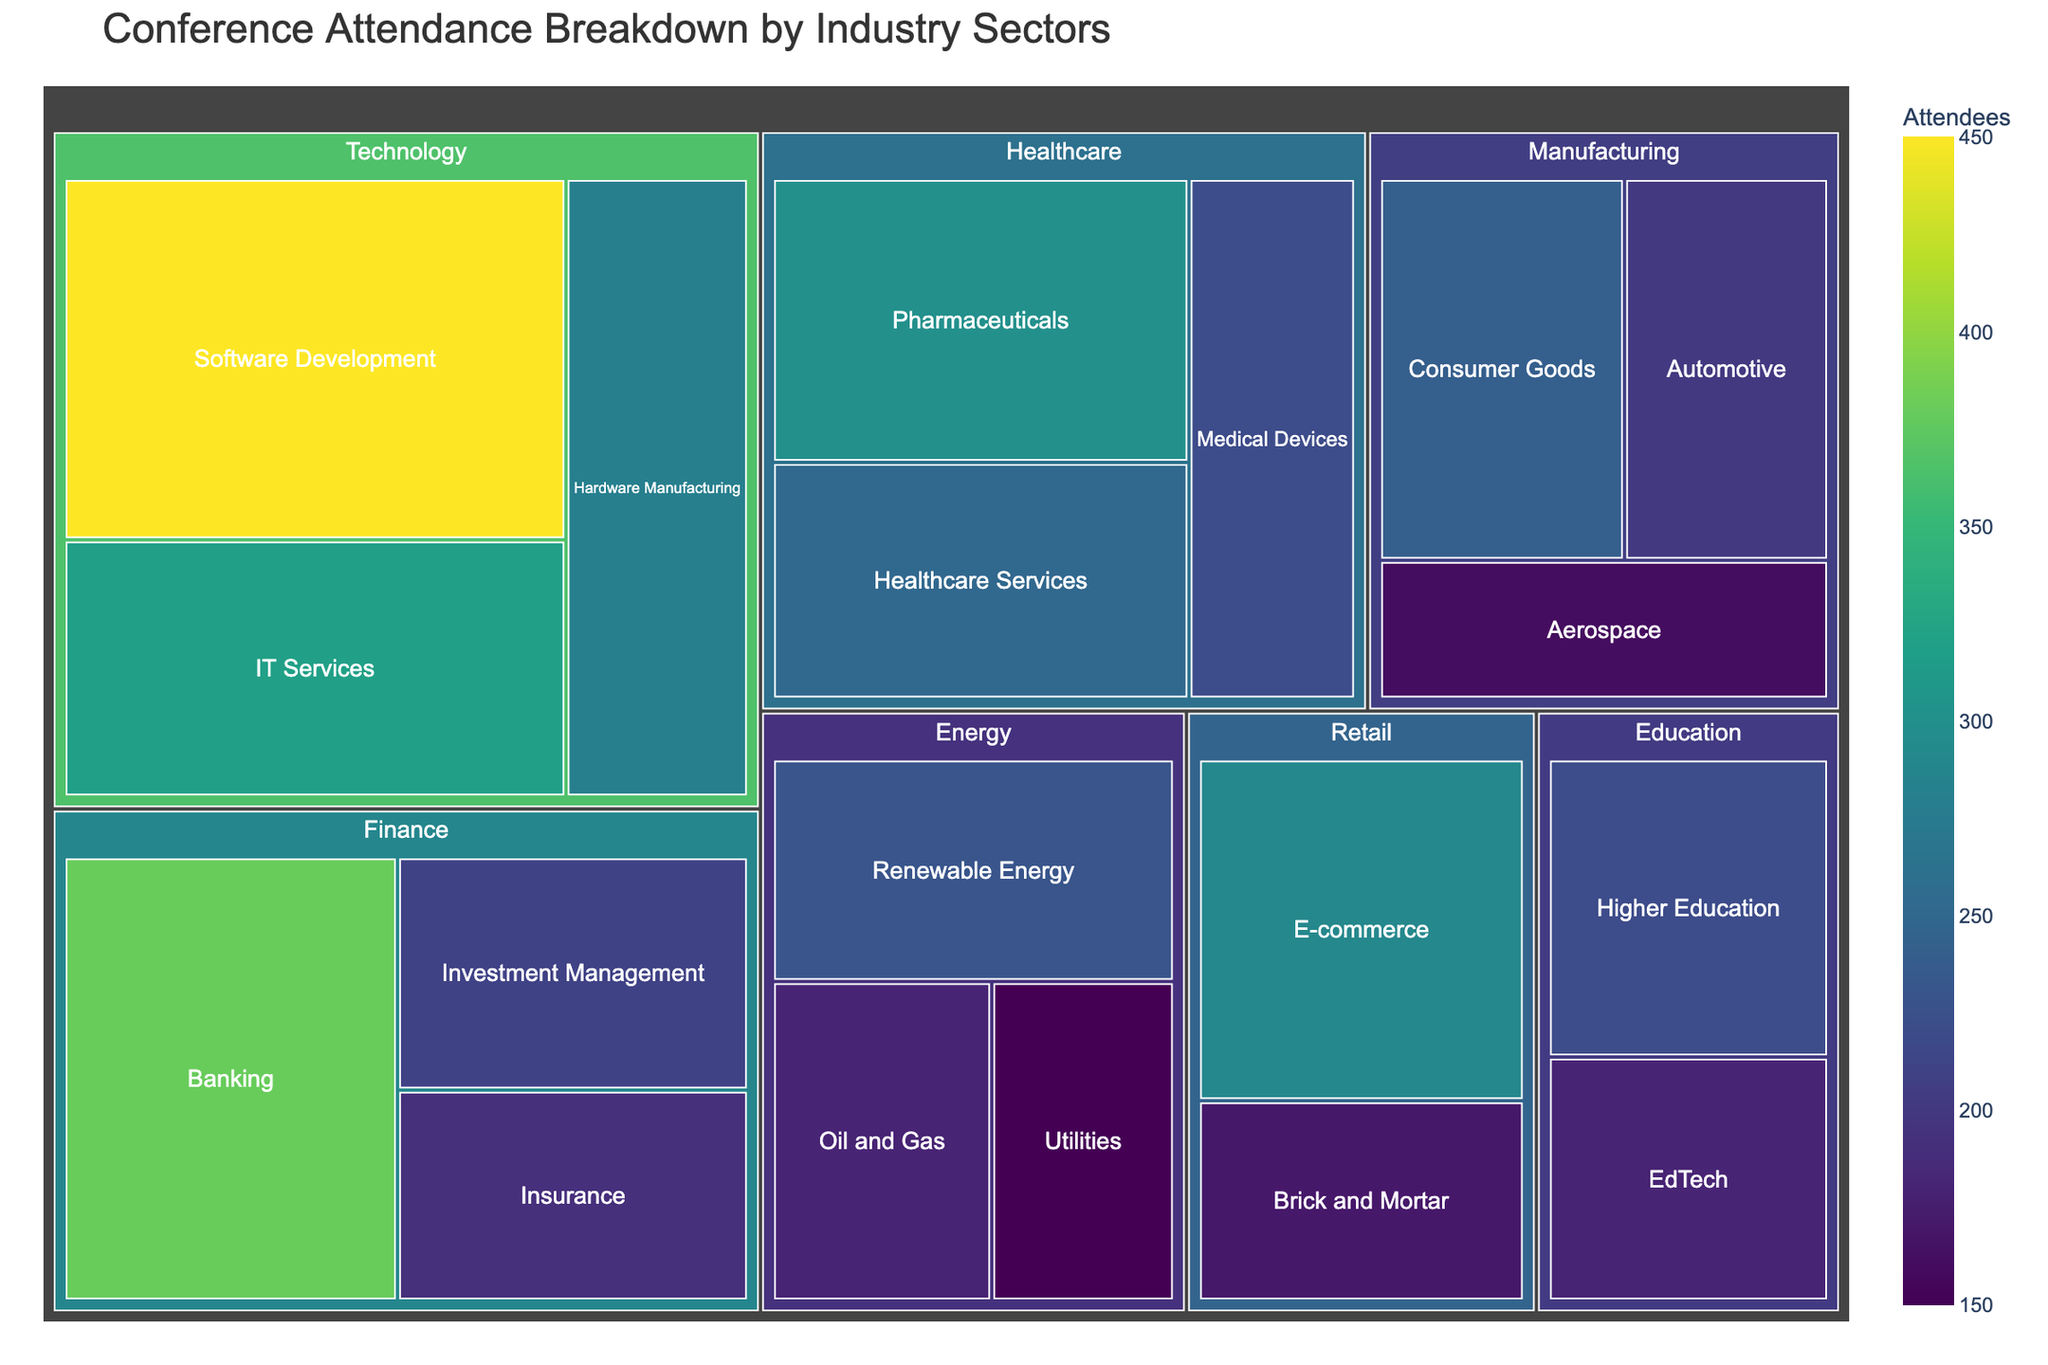what is the title of the treemap? The title of the treemap is located at the top of the figure and provides an overview of what the data represents.
Answer: Conference Attendance Breakdown by Industry Sectors how many industry sectors are represented in the treemap? By counting the unique 'Industry' labels in the treemap, we can determine the total number of industry sectors.
Answer: 6 which industry has the highest number of attendees? By comparing the sizes of the different industry blocks, we see that Technology has the largest area, indicating the highest number of attendees.
Answer: Technology what is the combined number of attendees for the Finance industry sectors? Summing the attendees from the Banking, Investment Management, and Insurance sectors gives us the total number: 380 + 210 + 190 = 780.
Answer: 780 which sector has the smallest number of attendees? By identifying the smallest block in the treemap, we find that 'Utilities' in the Energy industry has the least number of attendees.
Answer: Utilities how many attendees are there in the Medical Devices sector in Healthcare? Hovering over the Medical Devices block in the Healthcare industry shows the number of attendees.
Answer: 220 compare the number of attendees between Oil and Gas in Energy and Higher Education in Education. which one has more attendees? By comparing the sizes and values on hover, we see that Higher Education (220) has more attendees than Oil and Gas (180).
Answer: Higher Education what is the relationship between Renewable Energy and Hardware Manufacturing in terms of attendee numbers? By comparing the number of attendees, Renewable Energy (230) and Hardware Manufacturing (280), we see that Hardware Manufacturing has more attendees.
Answer: Hardware Manufacturing what is the combined number of attendees for all sectors in the Retail industry? Summing the attendees from E-commerce and Brick and Mortar sectors gives us the total number: 290 + 170 = 460.
Answer: 460 which industry has the second highest number of attendees and what is that number? By comparing the areas, the second largest after Technology is Finance. Adding up Banking, Investment Management, and Insurance: 380+210+190 = 780.
Answer: Finance with 780 attendees 